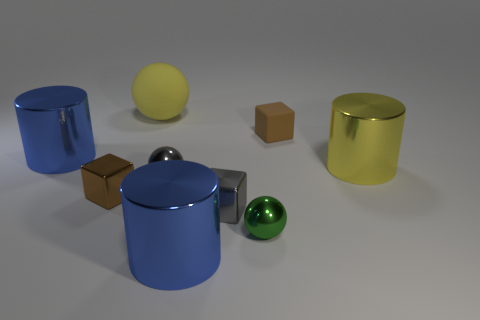Does the small gray cube have the same material as the small green object? Upon closer inspection, it seems the small gray cube and the small green sphere do not share the same texture or reflectivity characteristics. The gray cube has a matte finish with less pronounced reflections, indicating it likely has a different material than the glossy, reflective green sphere. 